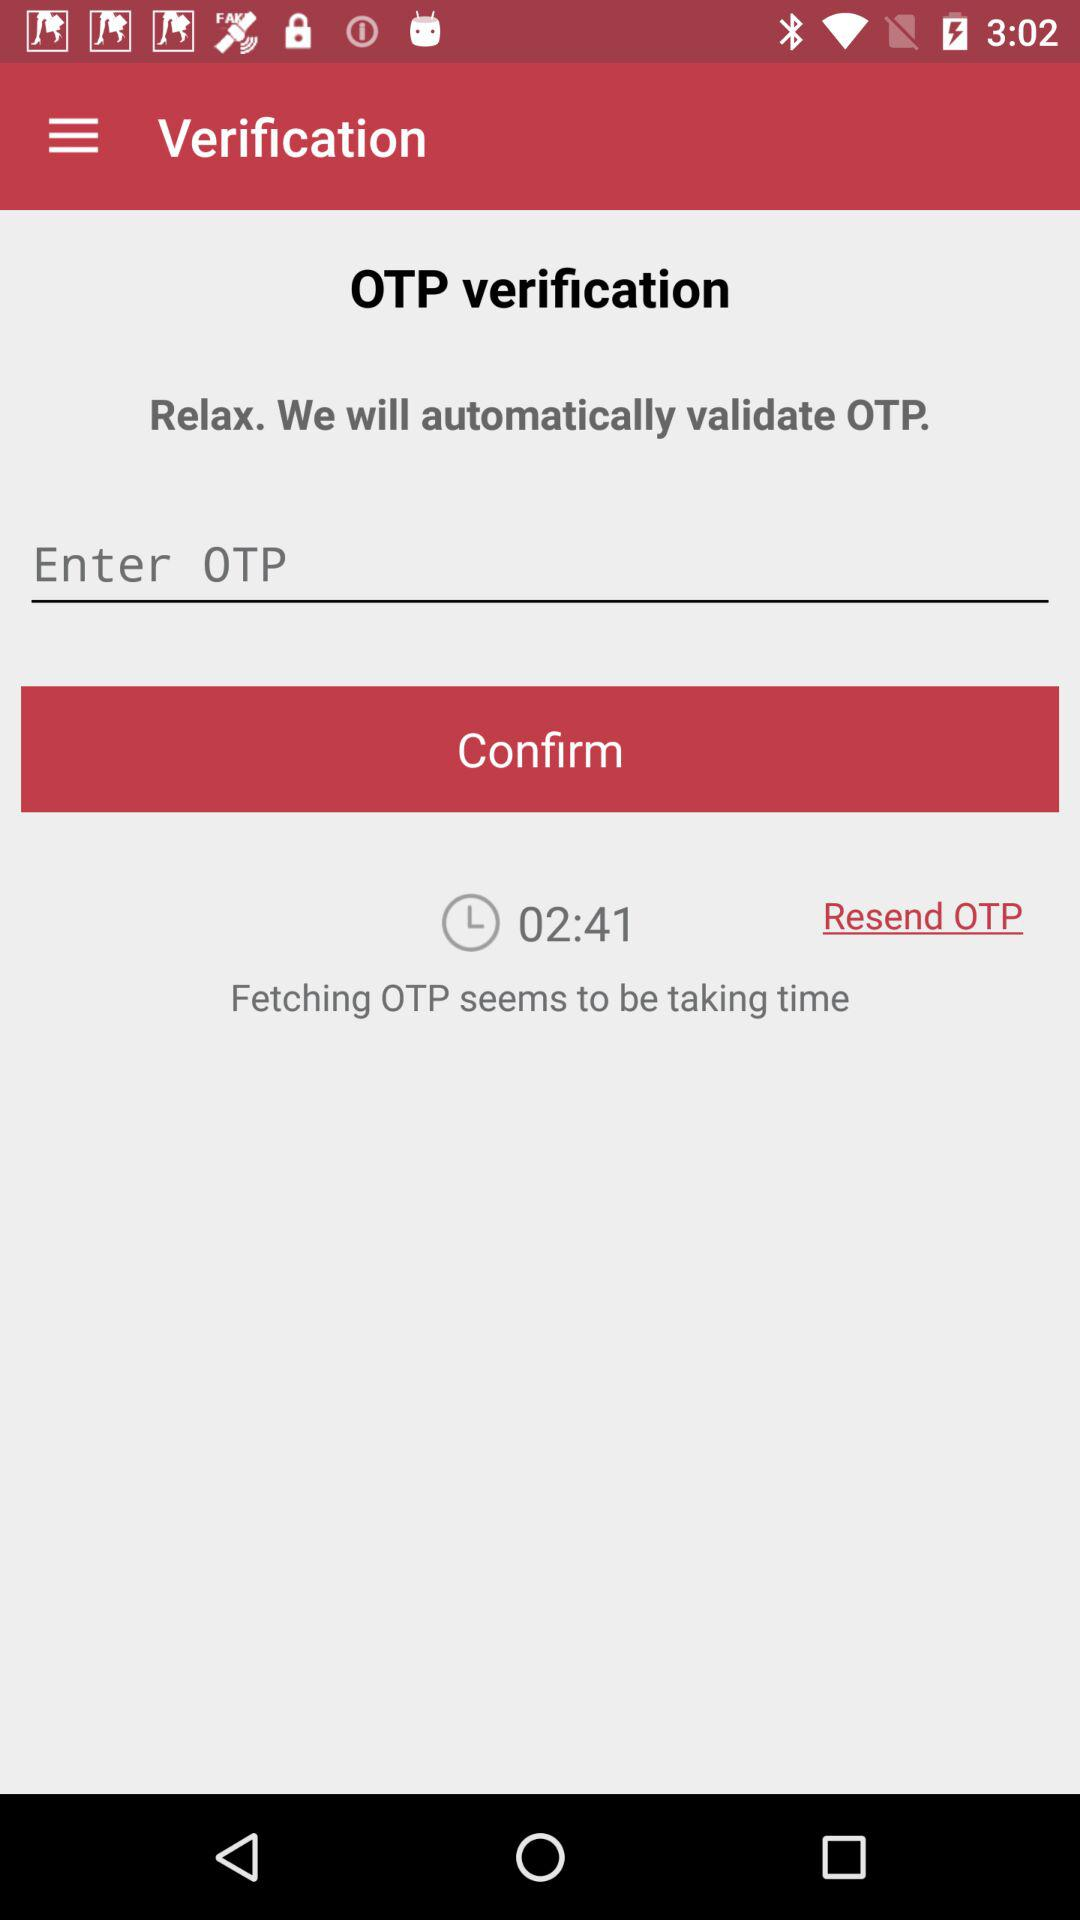How much time is left to fetch the OTP? The time left to fetch the OTP is 2 minutes 41 seconds. 